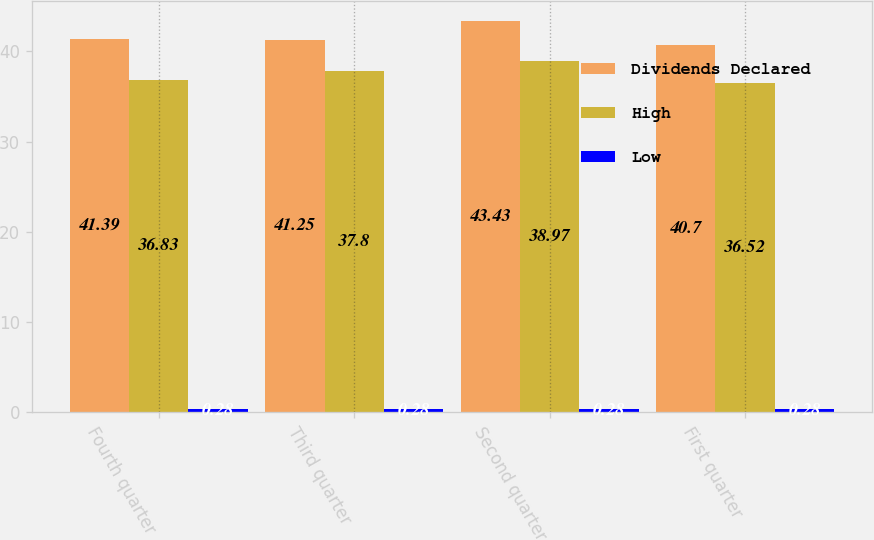<chart> <loc_0><loc_0><loc_500><loc_500><stacked_bar_chart><ecel><fcel>Fourth quarter<fcel>Third quarter<fcel>Second quarter<fcel>First quarter<nl><fcel>Dividends Declared<fcel>41.39<fcel>41.25<fcel>43.43<fcel>40.7<nl><fcel>High<fcel>36.83<fcel>37.8<fcel>38.97<fcel>36.52<nl><fcel>Low<fcel>0.28<fcel>0.28<fcel>0.28<fcel>0.28<nl></chart> 